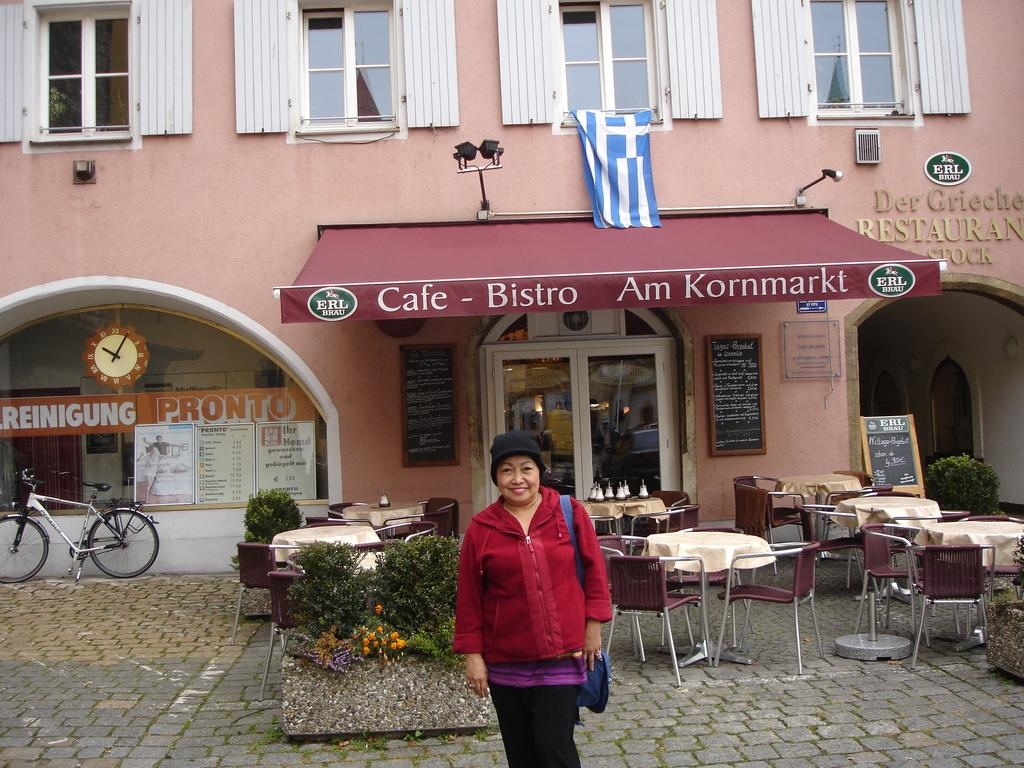Who is present in the image? There is a woman in the image. What is the woman standing in front of? The woman is standing in front of a building. What mode of transportation can be seen in the image? There is a cycle in the image. What type of furniture is visible in the image? There is a dining table in the image. What type of plant is present in the image? There is a plant in a pot in the image. What type of boat is present in the image? There is no boat present in the image. How does the country depicted in the image contribute to the scene? There is no country depicted in the image, as it features a woman standing in front of a building, a cycle, a dining table, and a plant in a pot. 